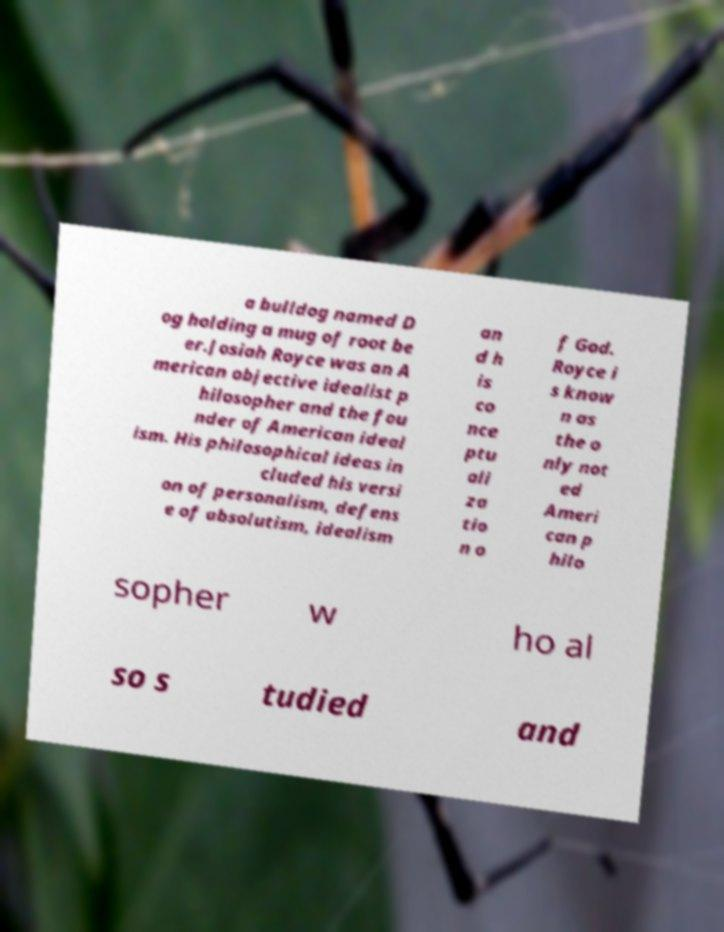Can you accurately transcribe the text from the provided image for me? a bulldog named D og holding a mug of root be er.Josiah Royce was an A merican objective idealist p hilosopher and the fou nder of American ideal ism. His philosophical ideas in cluded his versi on of personalism, defens e of absolutism, idealism an d h is co nce ptu ali za tio n o f God. Royce i s know n as the o nly not ed Ameri can p hilo sopher w ho al so s tudied and 